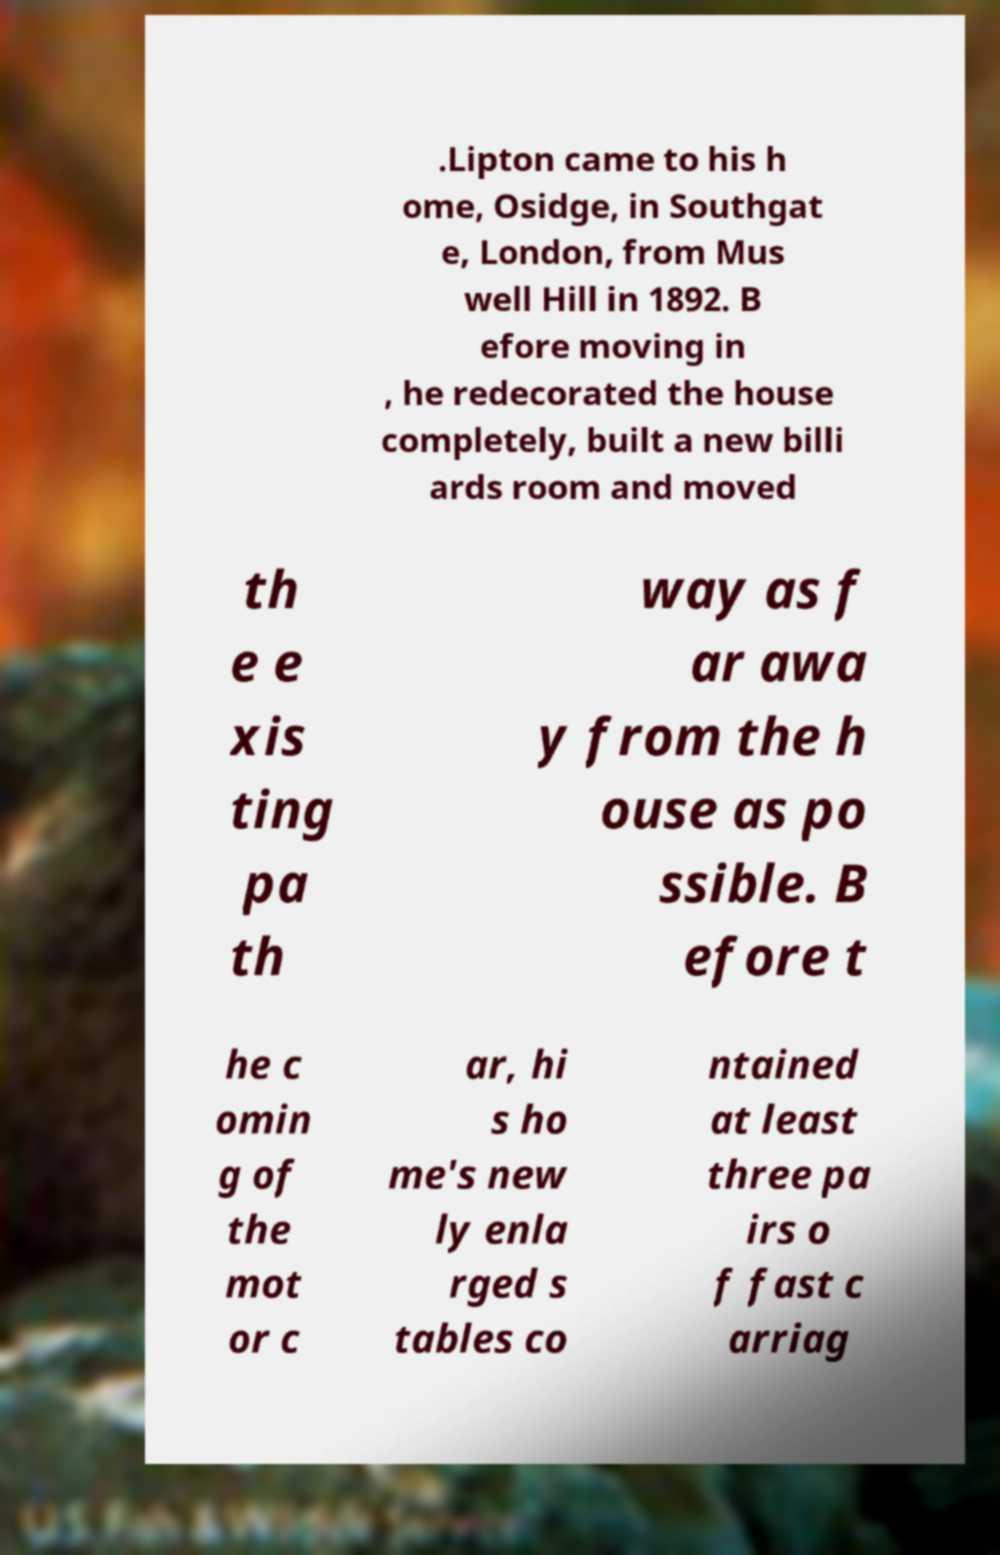I need the written content from this picture converted into text. Can you do that? .Lipton came to his h ome, Osidge, in Southgat e, London, from Mus well Hill in 1892. B efore moving in , he redecorated the house completely, built a new billi ards room and moved th e e xis ting pa th way as f ar awa y from the h ouse as po ssible. B efore t he c omin g of the mot or c ar, hi s ho me's new ly enla rged s tables co ntained at least three pa irs o f fast c arriag 